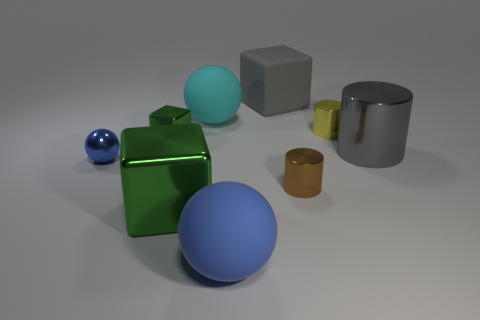Subtract 1 balls. How many balls are left? 2 Add 1 large gray cubes. How many objects exist? 10 Subtract all spheres. How many objects are left? 6 Subtract all cylinders. Subtract all big gray cylinders. How many objects are left? 5 Add 3 large gray metallic cylinders. How many large gray metallic cylinders are left? 4 Add 1 tiny yellow metallic cylinders. How many tiny yellow metallic cylinders exist? 2 Subtract 0 blue cylinders. How many objects are left? 9 